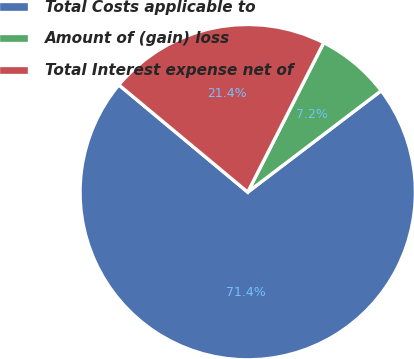Convert chart to OTSL. <chart><loc_0><loc_0><loc_500><loc_500><pie_chart><fcel>Total Costs applicable to<fcel>Amount of (gain) loss<fcel>Total Interest expense net of<nl><fcel>71.39%<fcel>7.17%<fcel>21.44%<nl></chart> 